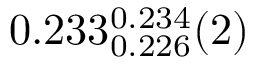<formula> <loc_0><loc_0><loc_500><loc_500>0 . 2 3 3 _ { 0 . 2 2 6 } ^ { 0 . 2 3 4 } ( 2 )</formula> 